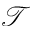Convert formula to latex. <formula><loc_0><loc_0><loc_500><loc_500>\mathcal { T }</formula> 